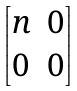Convert formula to latex. <formula><loc_0><loc_0><loc_500><loc_500>\begin{bmatrix} n & 0 \\ 0 & 0 \end{bmatrix}</formula> 